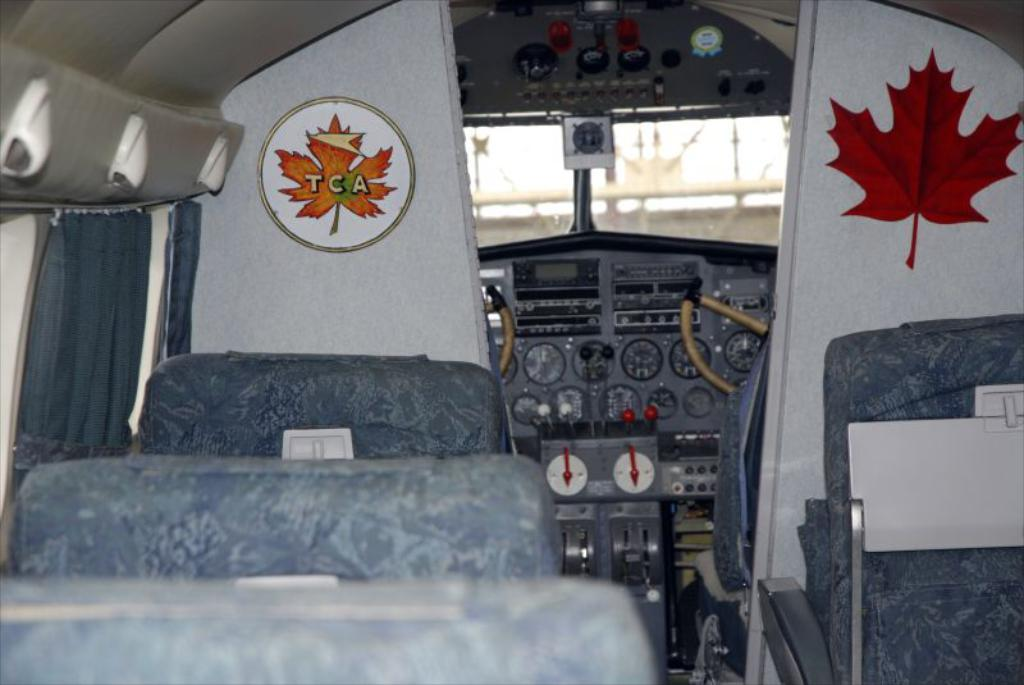What type of location is depicted in the image? The image shows an inside view of an airplane. What can be found inside the airplane? There are seats in the airplane. What feature is present on the left side of the image? There are curtains on the left side of the image. What part of the airplane can be seen in the middle of the image? The cockpit is visible in the middle of the image. How many chickens are present in the image? There are no chickens present in the image; it shows an inside view of an airplane. What type of fish can be seen swimming in the image? There are no fish present in the image; it shows an inside view of an airplane. 